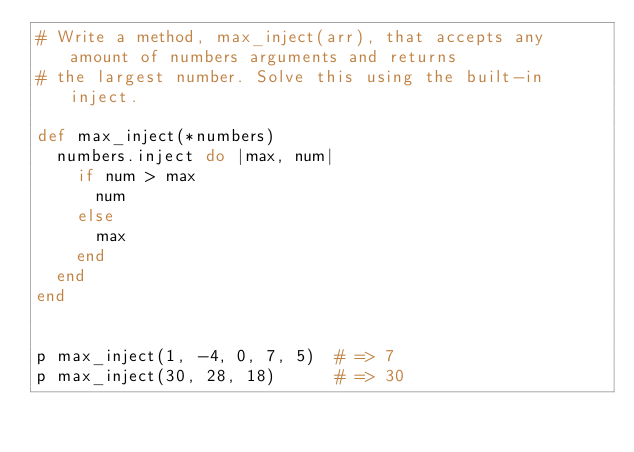<code> <loc_0><loc_0><loc_500><loc_500><_Ruby_># Write a method, max_inject(arr), that accepts any amount of numbers arguments and returns
# the largest number. Solve this using the built-in inject.

def max_inject(*numbers)
  numbers.inject do |max, num|
    if num > max
      num
    else
      max
    end
  end
end


p max_inject(1, -4, 0, 7, 5)  # => 7
p max_inject(30, 28, 18)      # => 30
</code> 